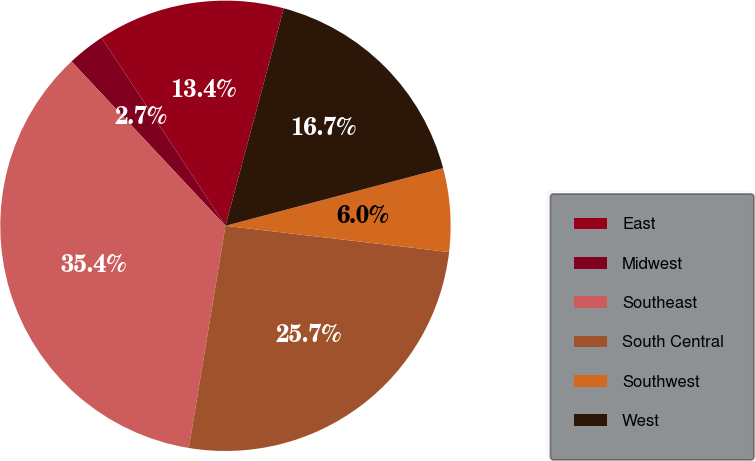Convert chart. <chart><loc_0><loc_0><loc_500><loc_500><pie_chart><fcel>East<fcel>Midwest<fcel>Southeast<fcel>South Central<fcel>Southwest<fcel>West<nl><fcel>13.44%<fcel>2.71%<fcel>35.42%<fcel>25.74%<fcel>5.98%<fcel>16.71%<nl></chart> 